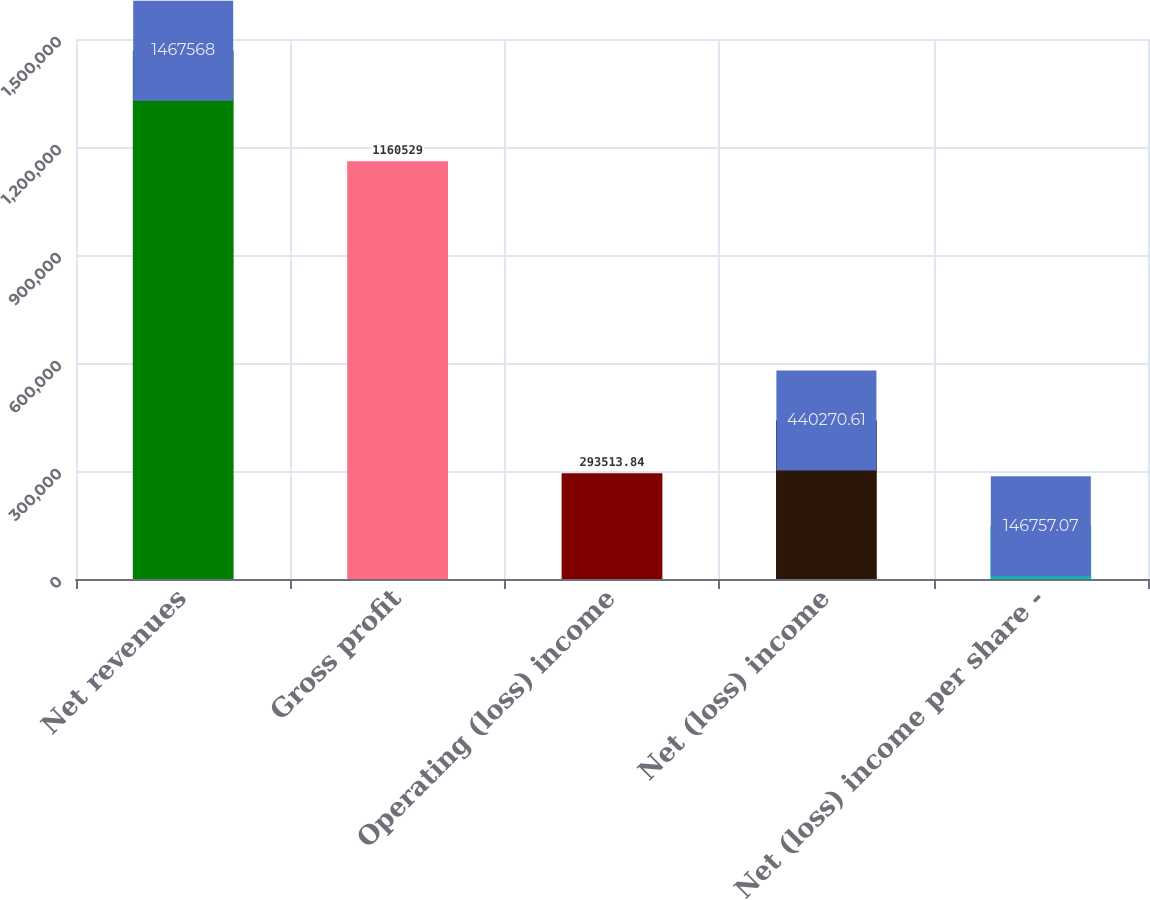<chart> <loc_0><loc_0><loc_500><loc_500><bar_chart><fcel>Net revenues<fcel>Gross profit<fcel>Operating (loss) income<fcel>Net (loss) income<fcel>Net (loss) income per share -<nl><fcel>1.46757e+06<fcel>1.16053e+06<fcel>293514<fcel>440271<fcel>146757<nl></chart> 